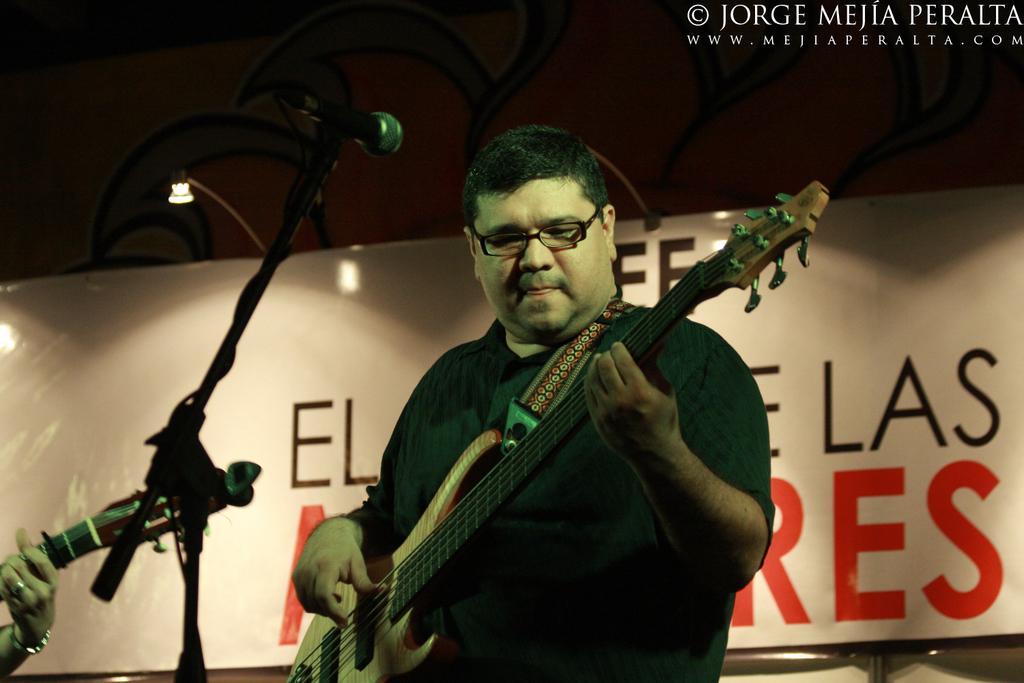Could you give a brief overview of what you see in this image? There is a man who is playing guitar. This is mike. On the background there is a banner and this is light. 